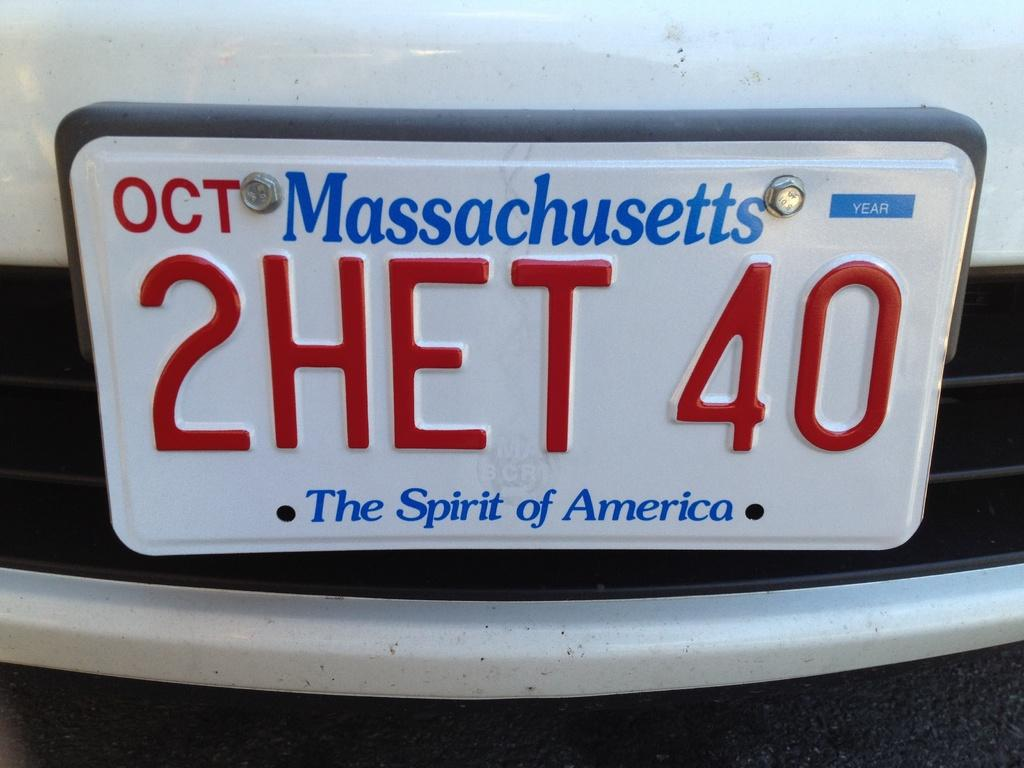<image>
Describe the image concisely. A white car has a license plate that says Massachusetts. 